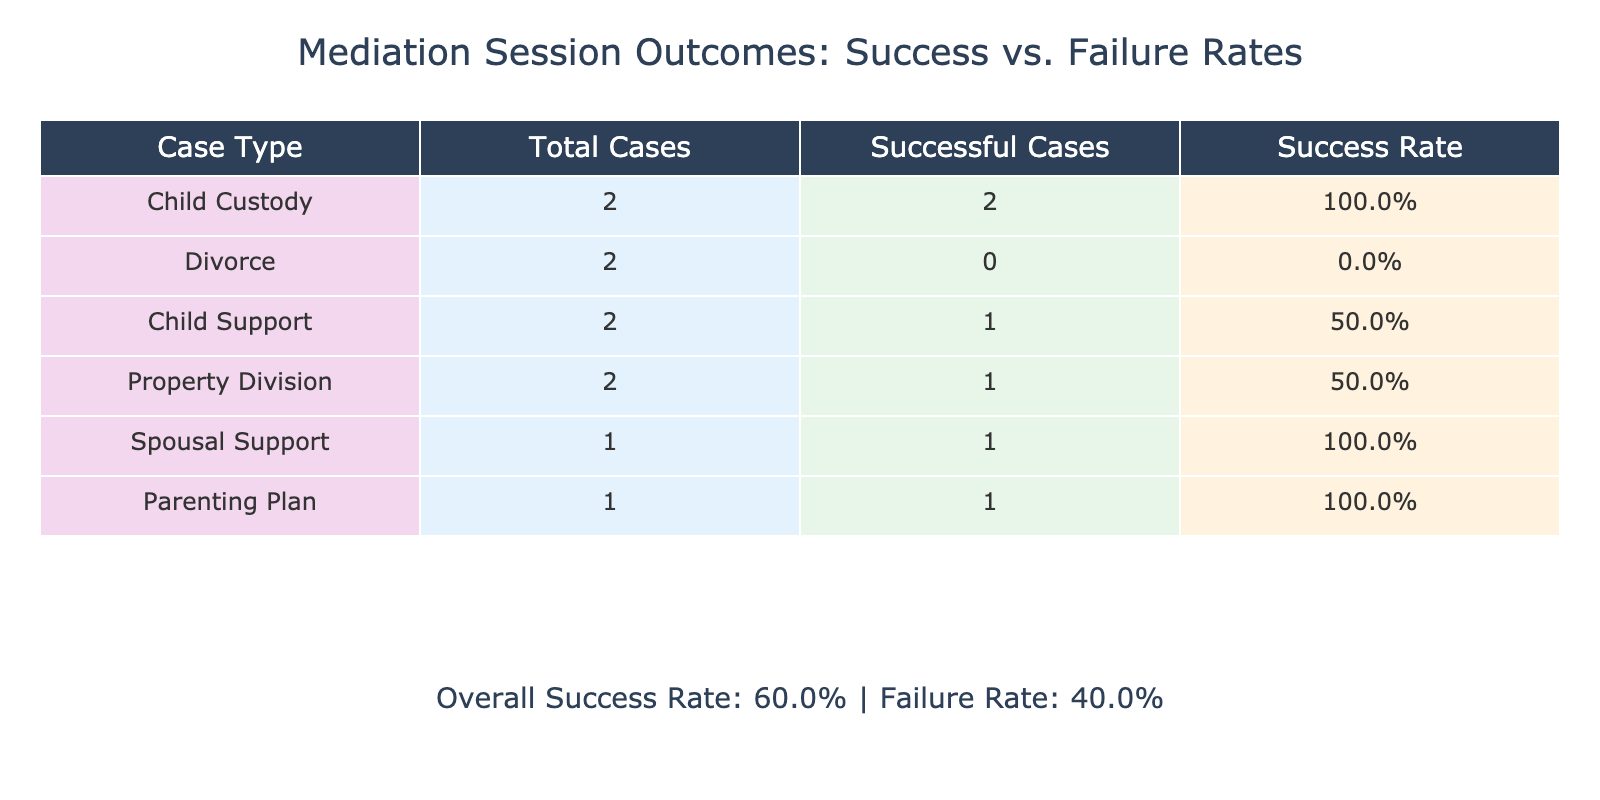What is the overall success rate in the mediation sessions? The overall success rate is provided in the annotation of the table, calculated as the percentage of successful outcomes from the total sessions. From the data, there are 5 successful cases and 5 unsuccessful cases, resulting in a success rate of (5/10)*100 = 50%.
Answer: 50% How many successful mediation sessions involve Child Custody? From the table, we look at the case types and count the successful outcomes. The Child Custody sessions (ID 1 and 5) both had successful outcomes, giving a total of 2 successful sessions.
Answer: 2 What is the success rate for the Divorce case type? There are 3 total Divorce sessions listed (IDs 2, 7, and one that has a successful outcome). Among these, only 1 session had a successful outcome, so the success rate is calculated as (1/3)*100 = 33.3%.
Answer: 33.3% Did any mediation sessions related to Property Division have a successful outcome? By reviewing the Property Division rows (IDs 4 and 10), we see that ID 10 had a successful outcome, while ID 4 did not. Therefore, there was at least one successful outcome in Property Division.
Answer: Yes Which case type had the highest success rate based on the sessions reviewed? To determine the highest success rate, we need to calculate the success rates for all case types. Child Custody has a success rate of 100% (2 successful out of 2), Child Support also has a success rate of 100% (2 successful out of 2), and others have lower rates. Therefore, both Child Custody and Child Support tie for the highest success rate.
Answer: Child Custody and Child Support (both 100%) If a case type had four sessions and all were successful, what would be its success rate? The number of successful sessions is 4 out of 4 total sessions, indicating a perfect success rate. The calculation is (4/4)*100 = 100%. Therefore, if a case has this scenario, the success rate is 100%.
Answer: 100% How many total participants attended the successful mediation sessions? To find the total participants, we sum the Total Participants for each successful session (IDs 1, 3, 5, 6, 8, and 10). These sessions had 4, 3, 3, 2, 3, and 3 participants respectively. Thus, the total is 4 + 3 + 3 + 2 + 3 + 3 = 18.
Answer: 18 What percentage of total sessions resulted in failure? To calculate the failure percentage, we look at the number of failed sessions (5 total failures) and divide it by the total number of sessions (10). The calculation goes as (5/10)*100 = 50%, showing that half of the mediation sessions were unsuccessful.
Answer: 50% Was there a successful outcome in the Spousal Support mediation session? By examining the row designated for Spousal Support (ID 6), it shows a successful outcome as marked 'Yes.' Thus, we can confirm that there was a successful outcome in this session.
Answer: Yes 